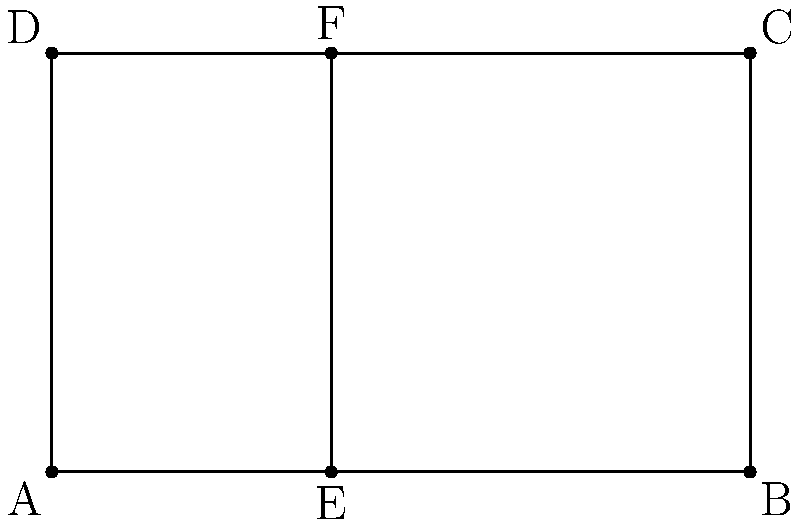In the diagram representing a simplified facade of a Dutch canal house, the golden ratio is applied to divide the width. If the total width of the house (AB) is 5 meters and the height (AD) is 3 meters, what is the length of AE in meters, rounded to two decimal places? To find the length of AE, we need to apply the golden ratio principle:

1. The golden ratio, denoted by φ (phi), is approximately 1.618033988749895.

2. In a golden ratio division, the ratio of the whole to the larger part is equal to the ratio of the larger part to the smaller part.

3. Let x be the length of AE. Then, 5-x is the length of EB.

4. According to the golden ratio principle:
   $\frac{5}{x} = \frac{x}{5-x} = φ$

5. This can be expressed as an equation:
   $x^2 = 5(5-x)$

6. Expanding the equation:
   $x^2 = 25 - 5x$

7. Rearranging to standard quadratic form:
   $x^2 + 5x - 25 = 0$

8. Using the quadratic formula $\frac{-b \pm \sqrt{b^2 - 4ac}}{2a}$:
   $x = \frac{-5 \pm \sqrt{25 + 100}}{2} = \frac{-5 \pm \sqrt{125}}{2}$

9. Taking the positive root:
   $x = \frac{-5 + \sqrt{125}}{2} ≈ 3.09016994374947$

10. Rounding to two decimal places:
    $x ≈ 3.09$ meters

Therefore, the length of AE is approximately 3.09 meters.
Answer: 3.09 meters 